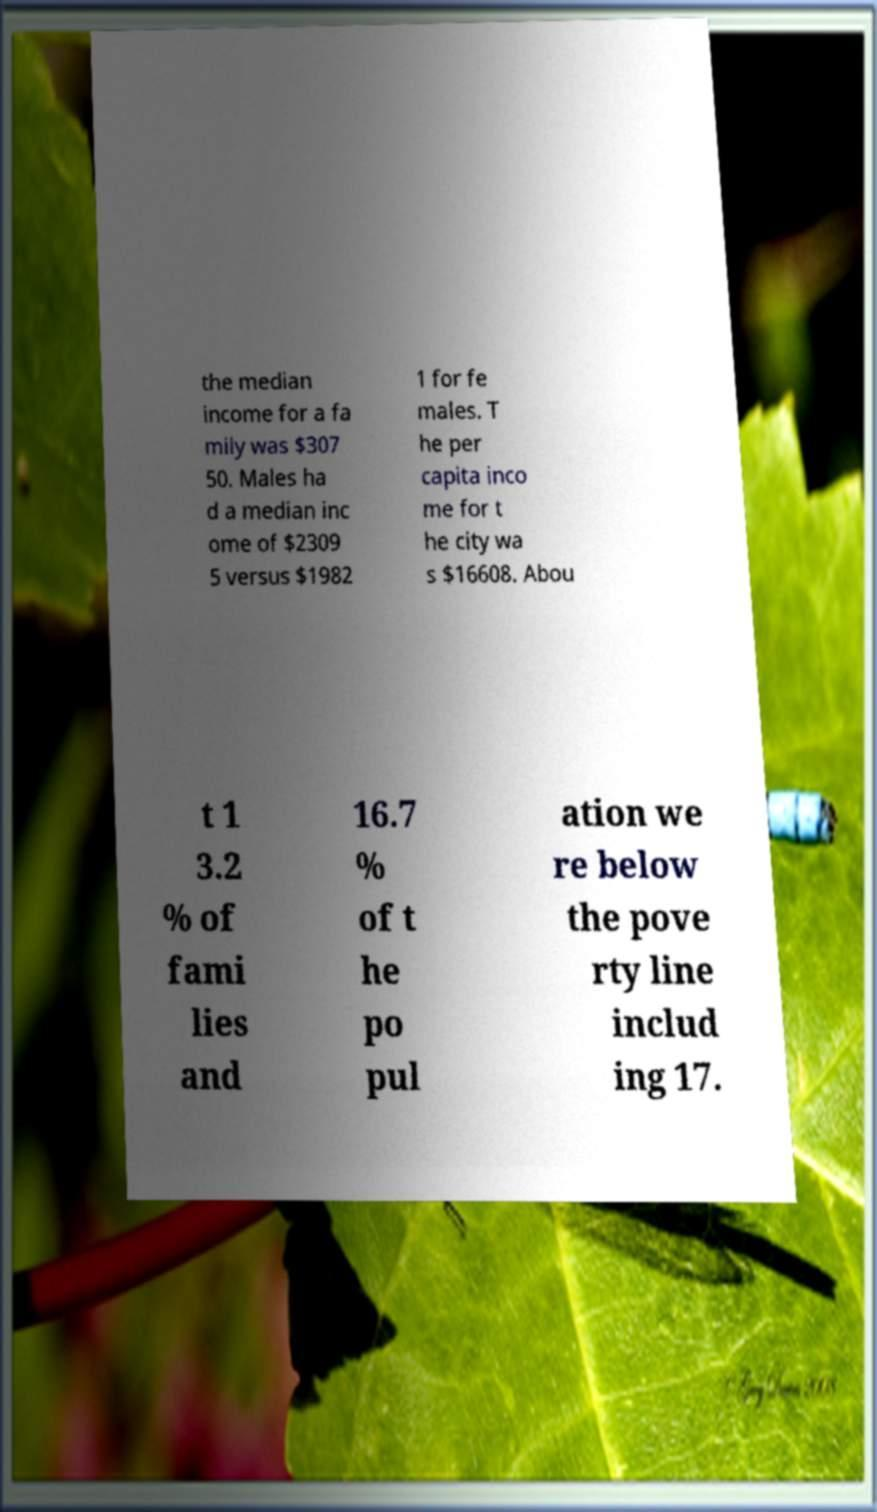Could you assist in decoding the text presented in this image and type it out clearly? the median income for a fa mily was $307 50. Males ha d a median inc ome of $2309 5 versus $1982 1 for fe males. T he per capita inco me for t he city wa s $16608. Abou t 1 3.2 % of fami lies and 16.7 % of t he po pul ation we re below the pove rty line includ ing 17. 